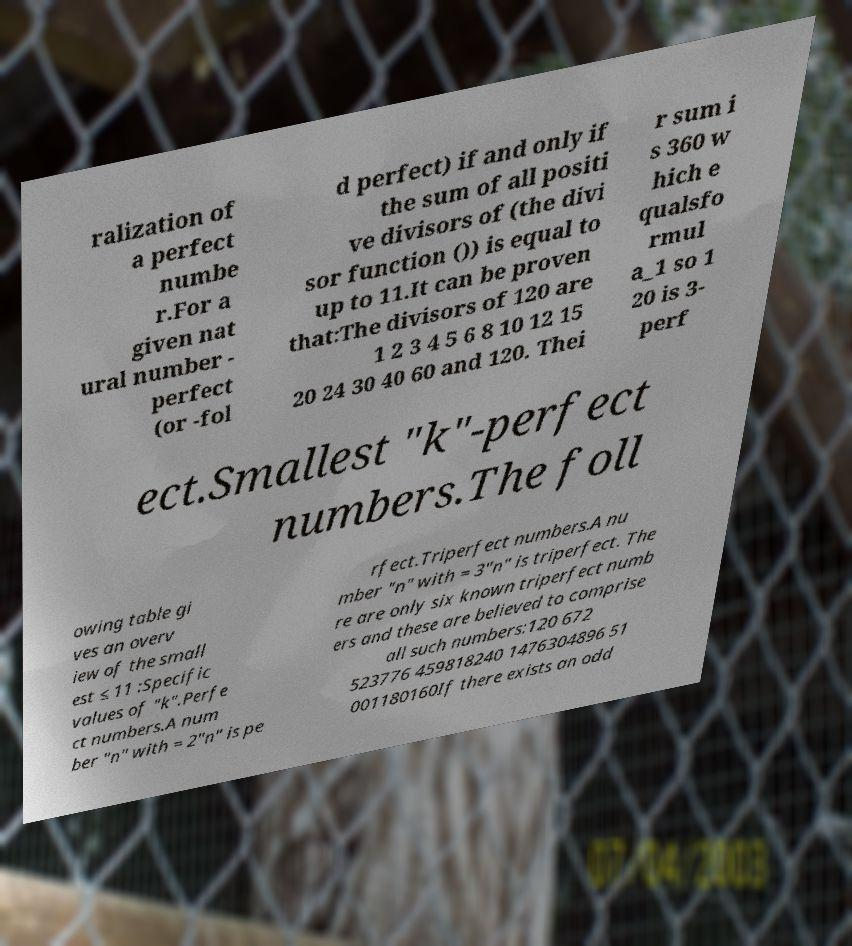Could you extract and type out the text from this image? ralization of a perfect numbe r.For a given nat ural number - perfect (or -fol d perfect) if and only if the sum of all positi ve divisors of (the divi sor function ()) is equal to up to 11.It can be proven that:The divisors of 120 are 1 2 3 4 5 6 8 10 12 15 20 24 30 40 60 and 120. Thei r sum i s 360 w hich e qualsfo rmul a_1 so 1 20 is 3- perf ect.Smallest "k"-perfect numbers.The foll owing table gi ves an overv iew of the small est ≤ 11 :Specific values of "k".Perfe ct numbers.A num ber "n" with = 2"n" is pe rfect.Triperfect numbers.A nu mber "n" with = 3"n" is triperfect. The re are only six known triperfect numb ers and these are believed to comprise all such numbers:120 672 523776 459818240 1476304896 51 001180160If there exists an odd 